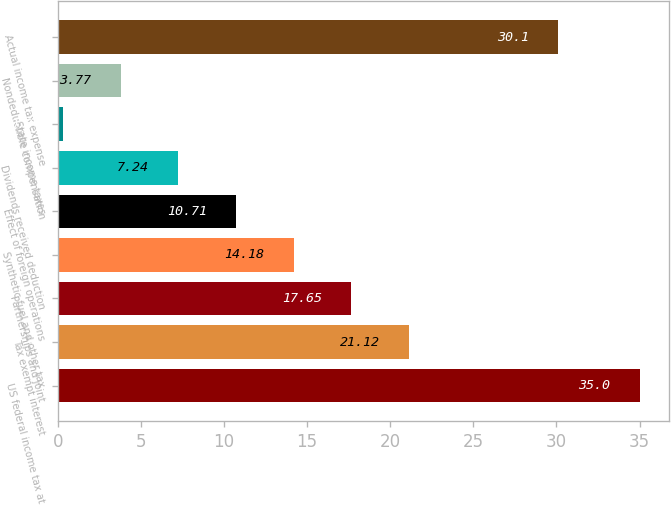Convert chart. <chart><loc_0><loc_0><loc_500><loc_500><bar_chart><fcel>US federal income tax at<fcel>Tax exempt interest<fcel>Partnerships and joint<fcel>Synthetic fuel and other tax<fcel>Effect of foreign operations<fcel>Dividends received deduction<fcel>State income taxes<fcel>Nondeductible compensation<fcel>Actual income tax expense<nl><fcel>35<fcel>21.12<fcel>17.65<fcel>14.18<fcel>10.71<fcel>7.24<fcel>0.3<fcel>3.77<fcel>30.1<nl></chart> 